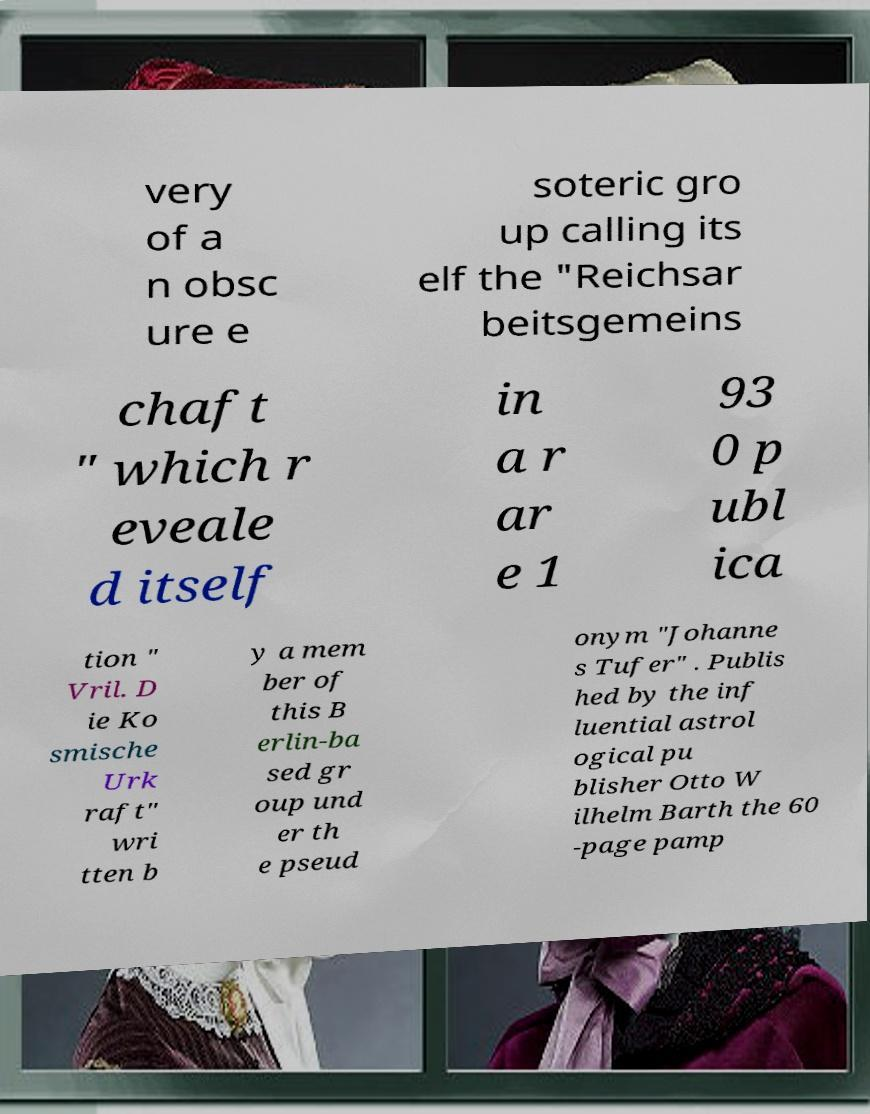Can you accurately transcribe the text from the provided image for me? very of a n obsc ure e soteric gro up calling its elf the "Reichsar beitsgemeins chaft " which r eveale d itself in a r ar e 1 93 0 p ubl ica tion " Vril. D ie Ko smische Urk raft" wri tten b y a mem ber of this B erlin-ba sed gr oup und er th e pseud onym "Johanne s Tufer" . Publis hed by the inf luential astrol ogical pu blisher Otto W ilhelm Barth the 60 -page pamp 